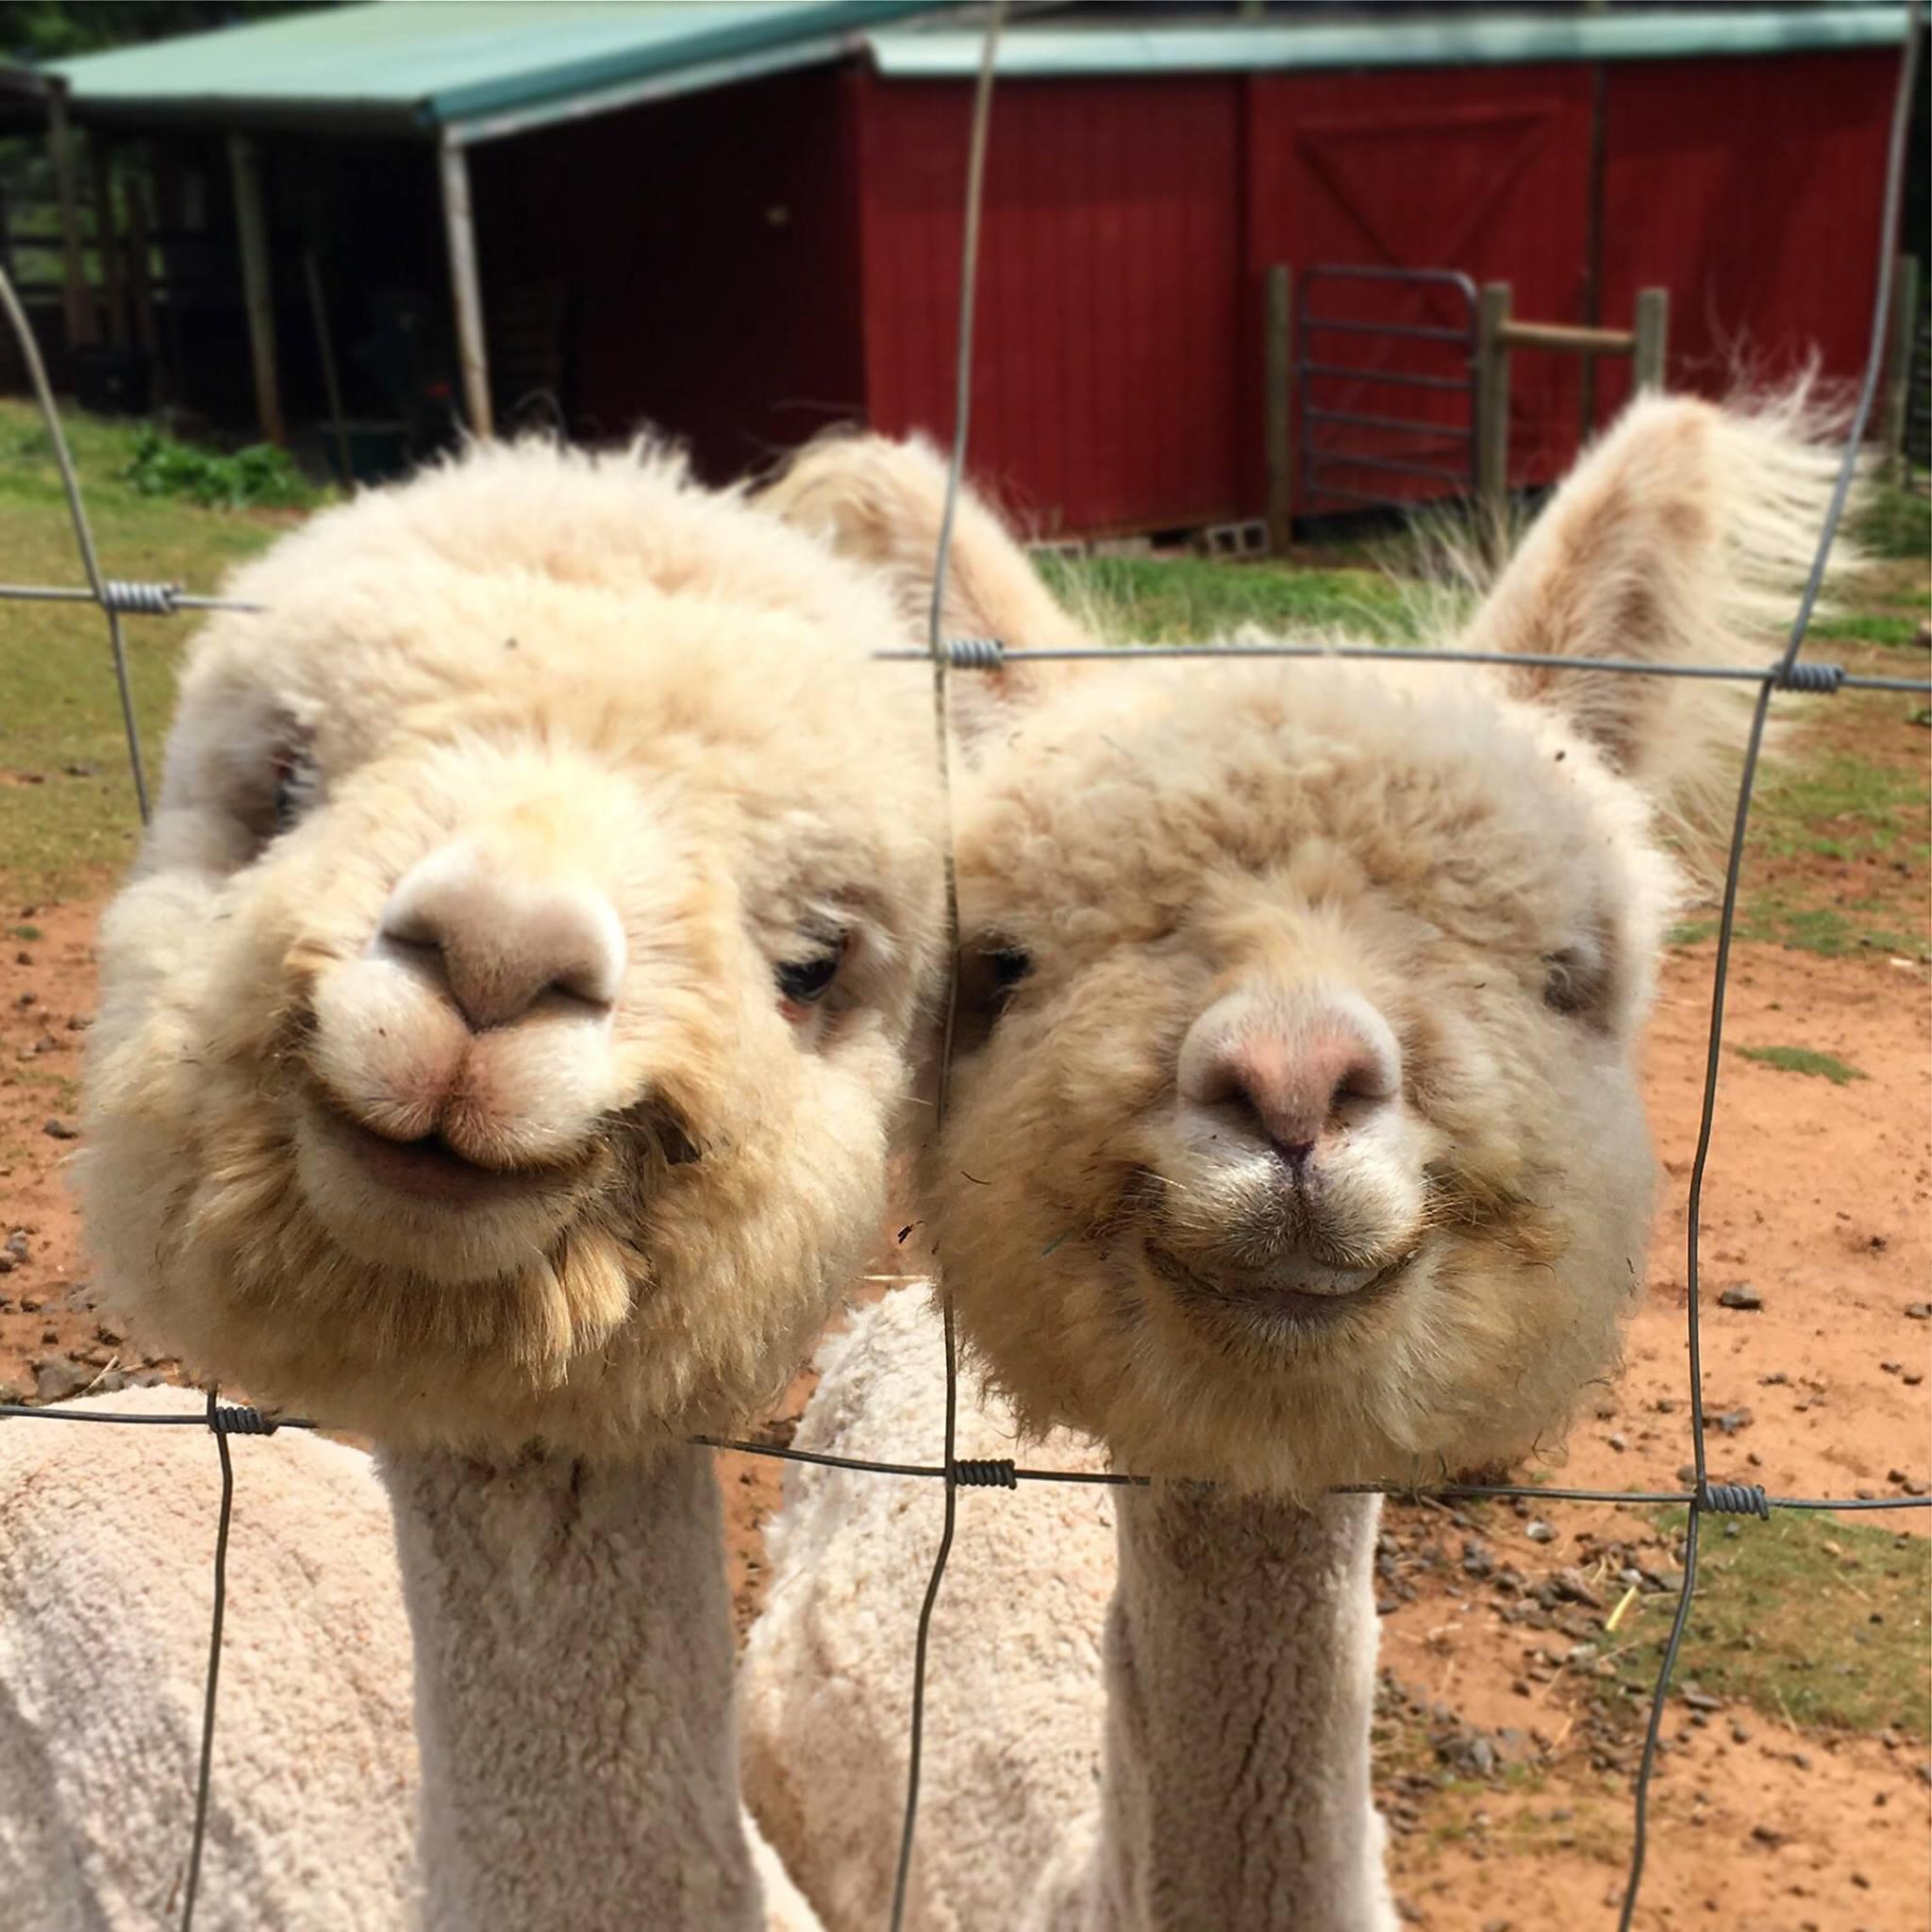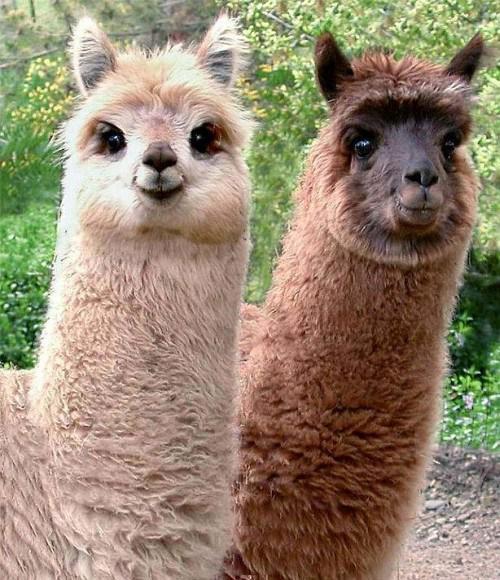The first image is the image on the left, the second image is the image on the right. Considering the images on both sides, is "One image contains two face-forward llamas with shaggy necks, and the other image includes at least one llama with a sheared neck and round head." valid? Answer yes or no. Yes. The first image is the image on the left, the second image is the image on the right. Examine the images to the left and right. Is the description "In one of the images there is a brown llama standing behind a paler llama." accurate? Answer yes or no. Yes. 